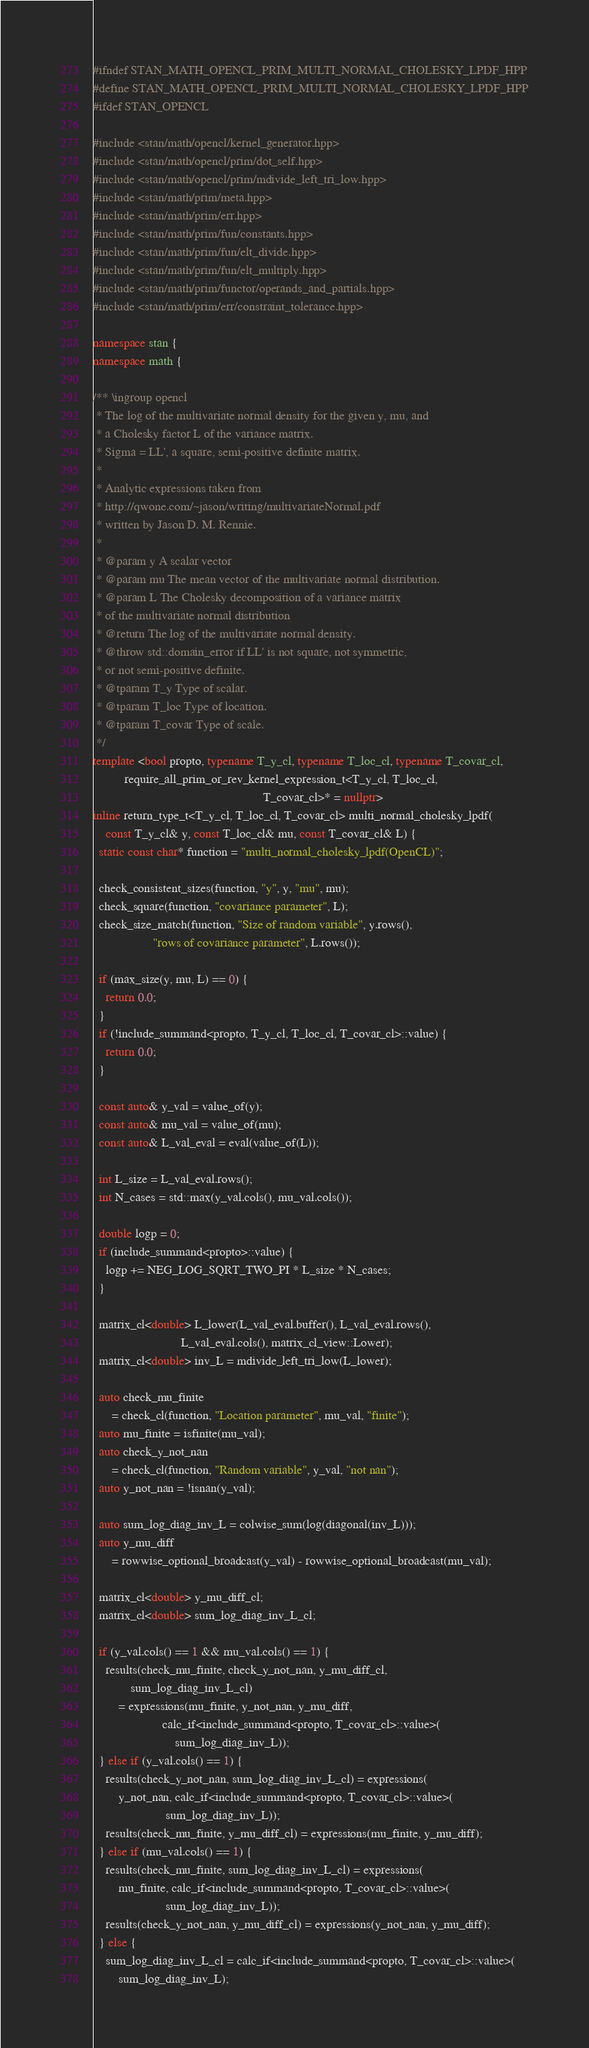Convert code to text. <code><loc_0><loc_0><loc_500><loc_500><_C++_>#ifndef STAN_MATH_OPENCL_PRIM_MULTI_NORMAL_CHOLESKY_LPDF_HPP
#define STAN_MATH_OPENCL_PRIM_MULTI_NORMAL_CHOLESKY_LPDF_HPP
#ifdef STAN_OPENCL

#include <stan/math/opencl/kernel_generator.hpp>
#include <stan/math/opencl/prim/dot_self.hpp>
#include <stan/math/opencl/prim/mdivide_left_tri_low.hpp>
#include <stan/math/prim/meta.hpp>
#include <stan/math/prim/err.hpp>
#include <stan/math/prim/fun/constants.hpp>
#include <stan/math/prim/fun/elt_divide.hpp>
#include <stan/math/prim/fun/elt_multiply.hpp>
#include <stan/math/prim/functor/operands_and_partials.hpp>
#include <stan/math/prim/err/constraint_tolerance.hpp>

namespace stan {
namespace math {

/** \ingroup opencl
 * The log of the multivariate normal density for the given y, mu, and
 * a Cholesky factor L of the variance matrix.
 * Sigma = LL', a square, semi-positive definite matrix.
 *
 * Analytic expressions taken from
 * http://qwone.com/~jason/writing/multivariateNormal.pdf
 * written by Jason D. M. Rennie.
 *
 * @param y A scalar vector
 * @param mu The mean vector of the multivariate normal distribution.
 * @param L The Cholesky decomposition of a variance matrix
 * of the multivariate normal distribution
 * @return The log of the multivariate normal density.
 * @throw std::domain_error if LL' is not square, not symmetric,
 * or not semi-positive definite.
 * @tparam T_y Type of scalar.
 * @tparam T_loc Type of location.
 * @tparam T_covar Type of scale.
 */
template <bool propto, typename T_y_cl, typename T_loc_cl, typename T_covar_cl,
          require_all_prim_or_rev_kernel_expression_t<T_y_cl, T_loc_cl,
                                                      T_covar_cl>* = nullptr>
inline return_type_t<T_y_cl, T_loc_cl, T_covar_cl> multi_normal_cholesky_lpdf(
    const T_y_cl& y, const T_loc_cl& mu, const T_covar_cl& L) {
  static const char* function = "multi_normal_cholesky_lpdf(OpenCL)";

  check_consistent_sizes(function, "y", y, "mu", mu);
  check_square(function, "covariance parameter", L);
  check_size_match(function, "Size of random variable", y.rows(),
                   "rows of covariance parameter", L.rows());

  if (max_size(y, mu, L) == 0) {
    return 0.0;
  }
  if (!include_summand<propto, T_y_cl, T_loc_cl, T_covar_cl>::value) {
    return 0.0;
  }

  const auto& y_val = value_of(y);
  const auto& mu_val = value_of(mu);
  const auto& L_val_eval = eval(value_of(L));

  int L_size = L_val_eval.rows();
  int N_cases = std::max(y_val.cols(), mu_val.cols());

  double logp = 0;
  if (include_summand<propto>::value) {
    logp += NEG_LOG_SQRT_TWO_PI * L_size * N_cases;
  }

  matrix_cl<double> L_lower(L_val_eval.buffer(), L_val_eval.rows(),
                            L_val_eval.cols(), matrix_cl_view::Lower);
  matrix_cl<double> inv_L = mdivide_left_tri_low(L_lower);

  auto check_mu_finite
      = check_cl(function, "Location parameter", mu_val, "finite");
  auto mu_finite = isfinite(mu_val);
  auto check_y_not_nan
      = check_cl(function, "Random variable", y_val, "not nan");
  auto y_not_nan = !isnan(y_val);

  auto sum_log_diag_inv_L = colwise_sum(log(diagonal(inv_L)));
  auto y_mu_diff
      = rowwise_optional_broadcast(y_val) - rowwise_optional_broadcast(mu_val);

  matrix_cl<double> y_mu_diff_cl;
  matrix_cl<double> sum_log_diag_inv_L_cl;

  if (y_val.cols() == 1 && mu_val.cols() == 1) {
    results(check_mu_finite, check_y_not_nan, y_mu_diff_cl,
            sum_log_diag_inv_L_cl)
        = expressions(mu_finite, y_not_nan, y_mu_diff,
                      calc_if<include_summand<propto, T_covar_cl>::value>(
                          sum_log_diag_inv_L));
  } else if (y_val.cols() == 1) {
    results(check_y_not_nan, sum_log_diag_inv_L_cl) = expressions(
        y_not_nan, calc_if<include_summand<propto, T_covar_cl>::value>(
                       sum_log_diag_inv_L));
    results(check_mu_finite, y_mu_diff_cl) = expressions(mu_finite, y_mu_diff);
  } else if (mu_val.cols() == 1) {
    results(check_mu_finite, sum_log_diag_inv_L_cl) = expressions(
        mu_finite, calc_if<include_summand<propto, T_covar_cl>::value>(
                       sum_log_diag_inv_L));
    results(check_y_not_nan, y_mu_diff_cl) = expressions(y_not_nan, y_mu_diff);
  } else {
    sum_log_diag_inv_L_cl = calc_if<include_summand<propto, T_covar_cl>::value>(
        sum_log_diag_inv_L);</code> 